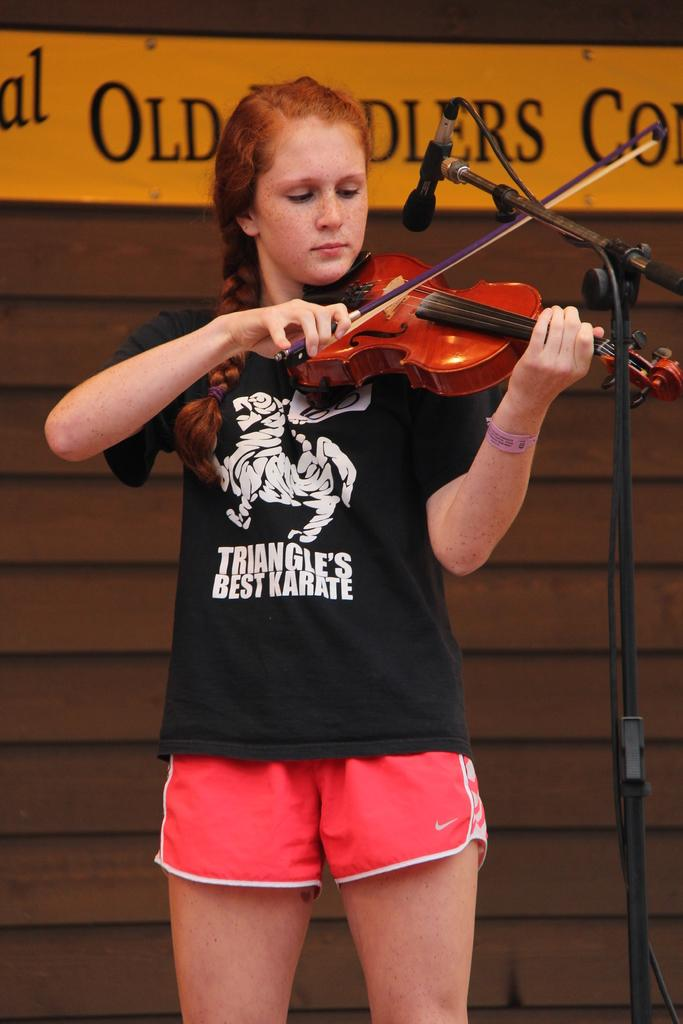<image>
Describe the image concisely. the girl playing the violin is wearing a karate shirt 